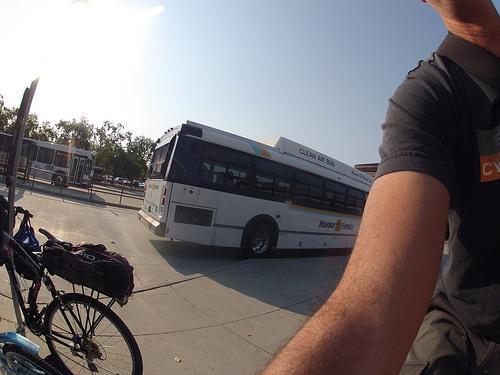How many people are ridin on elephants?
Give a very brief answer. 0. How many elephants are pictured?
Give a very brief answer. 0. 